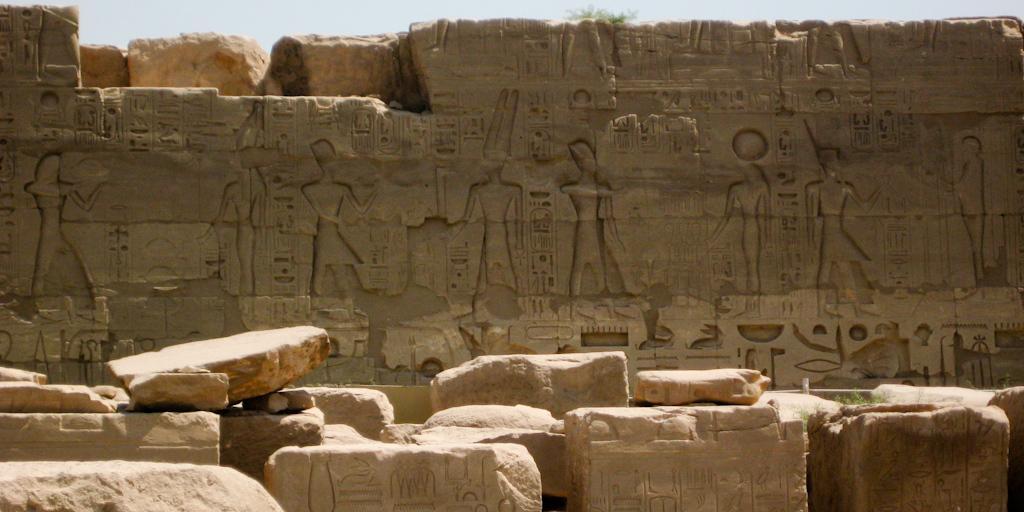How would you summarize this image in a sentence or two? In this image we can see sculptures on the walls and rocks. In the background we can see sky. 